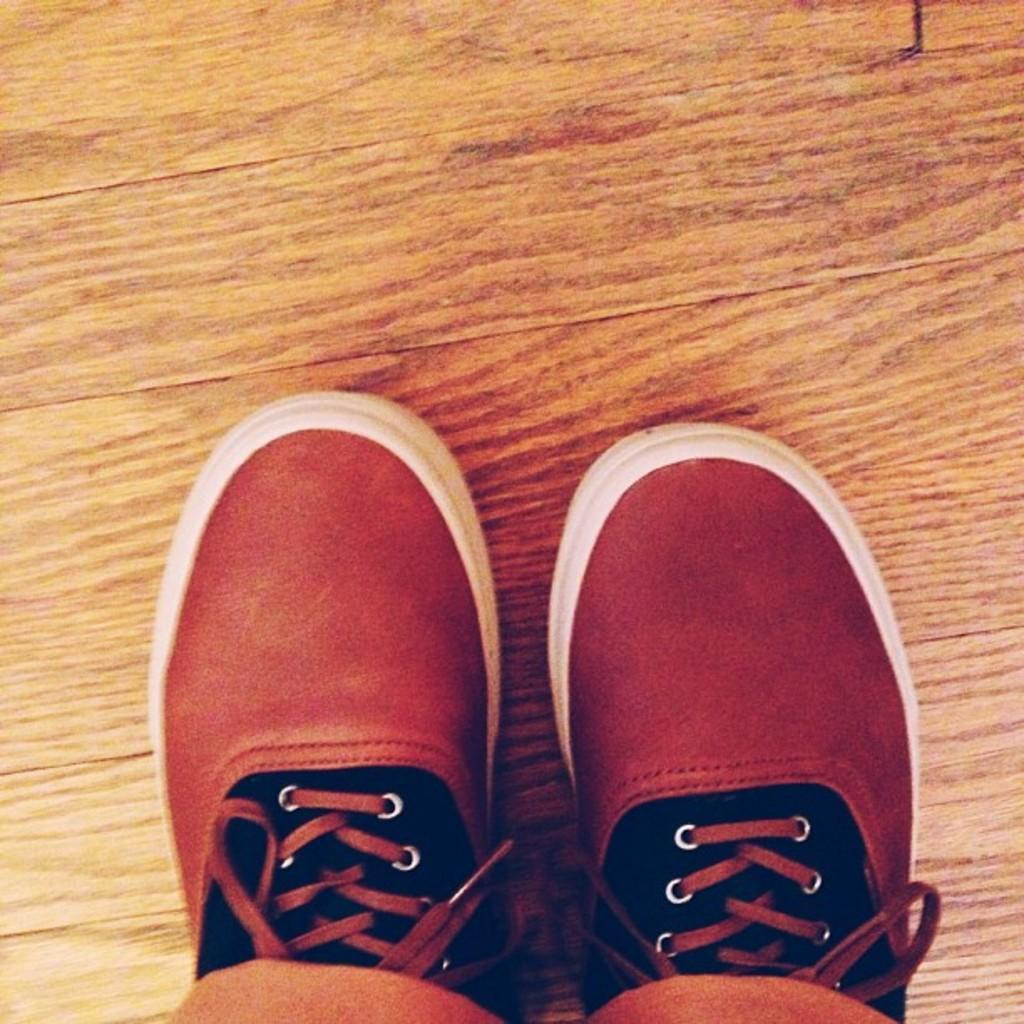What type of objects can be seen in the image? There are footwear in the image. What colors are the footwear? The footwear are in brown and black colors. What is the color of the surface where the footwear are placed? The footwear are on a brown color surface. Can you hear any music coming from the kitty's nest in the image? There is no kitty or nest present in the image, so it is not possible to hear any music coming from them. 